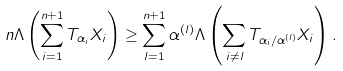<formula> <loc_0><loc_0><loc_500><loc_500>n \Lambda \left ( \sum _ { i = 1 } ^ { n + 1 } T _ { \alpha _ { i } } X _ { i } \right ) \geq \sum _ { l = 1 } ^ { n + 1 } \alpha ^ { ( l ) } \Lambda \left ( \sum _ { i \neq l } T _ { \alpha _ { i } / \alpha ^ { ( l ) } } X _ { i } \right ) .</formula> 